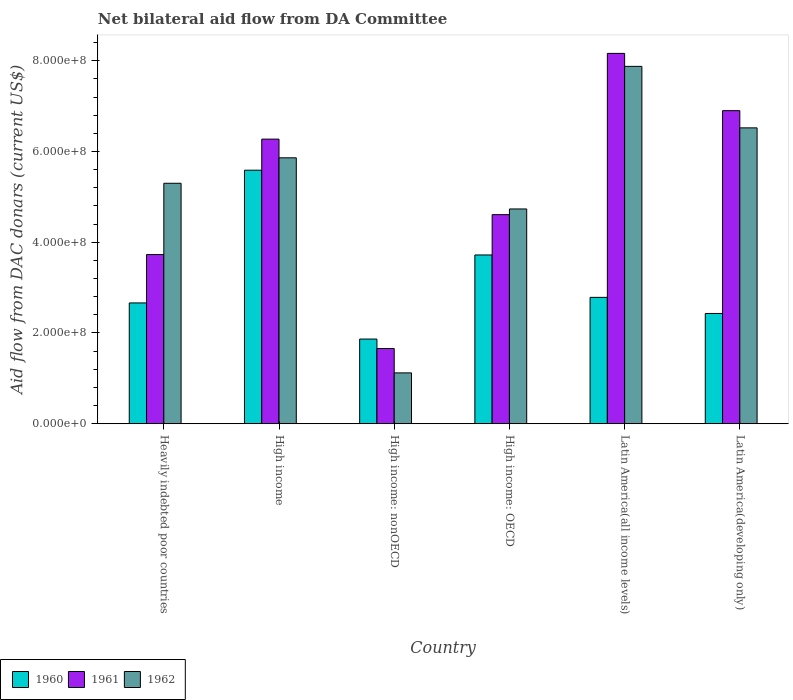How many groups of bars are there?
Provide a short and direct response. 6. How many bars are there on the 1st tick from the left?
Make the answer very short. 3. How many bars are there on the 5th tick from the right?
Your answer should be very brief. 3. What is the label of the 6th group of bars from the left?
Offer a terse response. Latin America(developing only). In how many cases, is the number of bars for a given country not equal to the number of legend labels?
Offer a very short reply. 0. What is the aid flow in in 1962 in High income: OECD?
Offer a very short reply. 4.73e+08. Across all countries, what is the maximum aid flow in in 1960?
Offer a very short reply. 5.59e+08. Across all countries, what is the minimum aid flow in in 1960?
Your answer should be compact. 1.87e+08. In which country was the aid flow in in 1960 maximum?
Offer a terse response. High income. In which country was the aid flow in in 1961 minimum?
Provide a succinct answer. High income: nonOECD. What is the total aid flow in in 1962 in the graph?
Offer a terse response. 3.14e+09. What is the difference between the aid flow in in 1961 in Heavily indebted poor countries and that in High income: nonOECD?
Give a very brief answer. 2.07e+08. What is the difference between the aid flow in in 1960 in High income: nonOECD and the aid flow in in 1961 in High income: OECD?
Your response must be concise. -2.74e+08. What is the average aid flow in in 1962 per country?
Offer a very short reply. 5.24e+08. What is the difference between the aid flow in of/in 1960 and aid flow in of/in 1961 in Latin America(all income levels)?
Your answer should be very brief. -5.38e+08. In how many countries, is the aid flow in in 1962 greater than 720000000 US$?
Your answer should be very brief. 1. What is the ratio of the aid flow in in 1962 in High income to that in Latin America(all income levels)?
Provide a succinct answer. 0.74. Is the aid flow in in 1961 in High income less than that in High income: nonOECD?
Your answer should be compact. No. What is the difference between the highest and the second highest aid flow in in 1960?
Provide a short and direct response. 1.87e+08. What is the difference between the highest and the lowest aid flow in in 1962?
Your answer should be compact. 6.76e+08. What does the 2nd bar from the left in High income represents?
Make the answer very short. 1961. Is it the case that in every country, the sum of the aid flow in in 1962 and aid flow in in 1960 is greater than the aid flow in in 1961?
Offer a very short reply. Yes. How many bars are there?
Provide a succinct answer. 18. How many countries are there in the graph?
Your answer should be compact. 6. Are the values on the major ticks of Y-axis written in scientific E-notation?
Provide a succinct answer. Yes. Does the graph contain grids?
Give a very brief answer. No. Where does the legend appear in the graph?
Keep it short and to the point. Bottom left. What is the title of the graph?
Provide a succinct answer. Net bilateral aid flow from DA Committee. What is the label or title of the Y-axis?
Ensure brevity in your answer.  Aid flow from DAC donars (current US$). What is the Aid flow from DAC donars (current US$) in 1960 in Heavily indebted poor countries?
Your answer should be very brief. 2.66e+08. What is the Aid flow from DAC donars (current US$) in 1961 in Heavily indebted poor countries?
Your response must be concise. 3.73e+08. What is the Aid flow from DAC donars (current US$) in 1962 in Heavily indebted poor countries?
Provide a short and direct response. 5.30e+08. What is the Aid flow from DAC donars (current US$) in 1960 in High income?
Provide a succinct answer. 5.59e+08. What is the Aid flow from DAC donars (current US$) of 1961 in High income?
Your answer should be very brief. 6.27e+08. What is the Aid flow from DAC donars (current US$) of 1962 in High income?
Ensure brevity in your answer.  5.86e+08. What is the Aid flow from DAC donars (current US$) of 1960 in High income: nonOECD?
Give a very brief answer. 1.87e+08. What is the Aid flow from DAC donars (current US$) of 1961 in High income: nonOECD?
Offer a very short reply. 1.66e+08. What is the Aid flow from DAC donars (current US$) of 1962 in High income: nonOECD?
Make the answer very short. 1.12e+08. What is the Aid flow from DAC donars (current US$) of 1960 in High income: OECD?
Your answer should be very brief. 3.72e+08. What is the Aid flow from DAC donars (current US$) in 1961 in High income: OECD?
Give a very brief answer. 4.61e+08. What is the Aid flow from DAC donars (current US$) of 1962 in High income: OECD?
Your answer should be very brief. 4.73e+08. What is the Aid flow from DAC donars (current US$) in 1960 in Latin America(all income levels)?
Give a very brief answer. 2.79e+08. What is the Aid flow from DAC donars (current US$) of 1961 in Latin America(all income levels)?
Give a very brief answer. 8.16e+08. What is the Aid flow from DAC donars (current US$) in 1962 in Latin America(all income levels)?
Your answer should be very brief. 7.88e+08. What is the Aid flow from DAC donars (current US$) in 1960 in Latin America(developing only)?
Keep it short and to the point. 2.43e+08. What is the Aid flow from DAC donars (current US$) in 1961 in Latin America(developing only)?
Provide a short and direct response. 6.90e+08. What is the Aid flow from DAC donars (current US$) of 1962 in Latin America(developing only)?
Provide a succinct answer. 6.52e+08. Across all countries, what is the maximum Aid flow from DAC donars (current US$) in 1960?
Your answer should be very brief. 5.59e+08. Across all countries, what is the maximum Aid flow from DAC donars (current US$) of 1961?
Ensure brevity in your answer.  8.16e+08. Across all countries, what is the maximum Aid flow from DAC donars (current US$) of 1962?
Ensure brevity in your answer.  7.88e+08. Across all countries, what is the minimum Aid flow from DAC donars (current US$) in 1960?
Provide a succinct answer. 1.87e+08. Across all countries, what is the minimum Aid flow from DAC donars (current US$) in 1961?
Provide a succinct answer. 1.66e+08. Across all countries, what is the minimum Aid flow from DAC donars (current US$) in 1962?
Ensure brevity in your answer.  1.12e+08. What is the total Aid flow from DAC donars (current US$) in 1960 in the graph?
Provide a succinct answer. 1.91e+09. What is the total Aid flow from DAC donars (current US$) of 1961 in the graph?
Offer a terse response. 3.13e+09. What is the total Aid flow from DAC donars (current US$) of 1962 in the graph?
Keep it short and to the point. 3.14e+09. What is the difference between the Aid flow from DAC donars (current US$) of 1960 in Heavily indebted poor countries and that in High income?
Keep it short and to the point. -2.92e+08. What is the difference between the Aid flow from DAC donars (current US$) in 1961 in Heavily indebted poor countries and that in High income?
Your answer should be very brief. -2.54e+08. What is the difference between the Aid flow from DAC donars (current US$) of 1962 in Heavily indebted poor countries and that in High income?
Provide a succinct answer. -5.61e+07. What is the difference between the Aid flow from DAC donars (current US$) in 1960 in Heavily indebted poor countries and that in High income: nonOECD?
Your answer should be very brief. 7.96e+07. What is the difference between the Aid flow from DAC donars (current US$) in 1961 in Heavily indebted poor countries and that in High income: nonOECD?
Your answer should be very brief. 2.07e+08. What is the difference between the Aid flow from DAC donars (current US$) in 1962 in Heavily indebted poor countries and that in High income: nonOECD?
Your answer should be very brief. 4.18e+08. What is the difference between the Aid flow from DAC donars (current US$) in 1960 in Heavily indebted poor countries and that in High income: OECD?
Give a very brief answer. -1.06e+08. What is the difference between the Aid flow from DAC donars (current US$) in 1961 in Heavily indebted poor countries and that in High income: OECD?
Offer a terse response. -8.80e+07. What is the difference between the Aid flow from DAC donars (current US$) of 1962 in Heavily indebted poor countries and that in High income: OECD?
Make the answer very short. 5.66e+07. What is the difference between the Aid flow from DAC donars (current US$) of 1960 in Heavily indebted poor countries and that in Latin America(all income levels)?
Ensure brevity in your answer.  -1.23e+07. What is the difference between the Aid flow from DAC donars (current US$) of 1961 in Heavily indebted poor countries and that in Latin America(all income levels)?
Offer a terse response. -4.43e+08. What is the difference between the Aid flow from DAC donars (current US$) in 1962 in Heavily indebted poor countries and that in Latin America(all income levels)?
Provide a short and direct response. -2.58e+08. What is the difference between the Aid flow from DAC donars (current US$) in 1960 in Heavily indebted poor countries and that in Latin America(developing only)?
Provide a short and direct response. 2.32e+07. What is the difference between the Aid flow from DAC donars (current US$) in 1961 in Heavily indebted poor countries and that in Latin America(developing only)?
Offer a very short reply. -3.17e+08. What is the difference between the Aid flow from DAC donars (current US$) in 1962 in Heavily indebted poor countries and that in Latin America(developing only)?
Your response must be concise. -1.22e+08. What is the difference between the Aid flow from DAC donars (current US$) in 1960 in High income and that in High income: nonOECD?
Your response must be concise. 3.72e+08. What is the difference between the Aid flow from DAC donars (current US$) in 1961 in High income and that in High income: nonOECD?
Provide a succinct answer. 4.61e+08. What is the difference between the Aid flow from DAC donars (current US$) in 1962 in High income and that in High income: nonOECD?
Your answer should be very brief. 4.74e+08. What is the difference between the Aid flow from DAC donars (current US$) of 1960 in High income and that in High income: OECD?
Give a very brief answer. 1.87e+08. What is the difference between the Aid flow from DAC donars (current US$) in 1961 in High income and that in High income: OECD?
Ensure brevity in your answer.  1.66e+08. What is the difference between the Aid flow from DAC donars (current US$) in 1962 in High income and that in High income: OECD?
Offer a very short reply. 1.13e+08. What is the difference between the Aid flow from DAC donars (current US$) of 1960 in High income and that in Latin America(all income levels)?
Give a very brief answer. 2.80e+08. What is the difference between the Aid flow from DAC donars (current US$) in 1961 in High income and that in Latin America(all income levels)?
Your answer should be very brief. -1.89e+08. What is the difference between the Aid flow from DAC donars (current US$) in 1962 in High income and that in Latin America(all income levels)?
Your response must be concise. -2.02e+08. What is the difference between the Aid flow from DAC donars (current US$) of 1960 in High income and that in Latin America(developing only)?
Keep it short and to the point. 3.16e+08. What is the difference between the Aid flow from DAC donars (current US$) of 1961 in High income and that in Latin America(developing only)?
Give a very brief answer. -6.27e+07. What is the difference between the Aid flow from DAC donars (current US$) of 1962 in High income and that in Latin America(developing only)?
Provide a short and direct response. -6.60e+07. What is the difference between the Aid flow from DAC donars (current US$) of 1960 in High income: nonOECD and that in High income: OECD?
Provide a succinct answer. -1.85e+08. What is the difference between the Aid flow from DAC donars (current US$) in 1961 in High income: nonOECD and that in High income: OECD?
Provide a succinct answer. -2.95e+08. What is the difference between the Aid flow from DAC donars (current US$) in 1962 in High income: nonOECD and that in High income: OECD?
Your answer should be very brief. -3.61e+08. What is the difference between the Aid flow from DAC donars (current US$) of 1960 in High income: nonOECD and that in Latin America(all income levels)?
Ensure brevity in your answer.  -9.19e+07. What is the difference between the Aid flow from DAC donars (current US$) of 1961 in High income: nonOECD and that in Latin America(all income levels)?
Give a very brief answer. -6.50e+08. What is the difference between the Aid flow from DAC donars (current US$) of 1962 in High income: nonOECD and that in Latin America(all income levels)?
Provide a short and direct response. -6.76e+08. What is the difference between the Aid flow from DAC donars (current US$) of 1960 in High income: nonOECD and that in Latin America(developing only)?
Ensure brevity in your answer.  -5.64e+07. What is the difference between the Aid flow from DAC donars (current US$) in 1961 in High income: nonOECD and that in Latin America(developing only)?
Offer a very short reply. -5.24e+08. What is the difference between the Aid flow from DAC donars (current US$) in 1962 in High income: nonOECD and that in Latin America(developing only)?
Offer a terse response. -5.40e+08. What is the difference between the Aid flow from DAC donars (current US$) in 1960 in High income: OECD and that in Latin America(all income levels)?
Your response must be concise. 9.35e+07. What is the difference between the Aid flow from DAC donars (current US$) of 1961 in High income: OECD and that in Latin America(all income levels)?
Your answer should be compact. -3.55e+08. What is the difference between the Aid flow from DAC donars (current US$) in 1962 in High income: OECD and that in Latin America(all income levels)?
Ensure brevity in your answer.  -3.14e+08. What is the difference between the Aid flow from DAC donars (current US$) of 1960 in High income: OECD and that in Latin America(developing only)?
Your answer should be compact. 1.29e+08. What is the difference between the Aid flow from DAC donars (current US$) of 1961 in High income: OECD and that in Latin America(developing only)?
Provide a succinct answer. -2.29e+08. What is the difference between the Aid flow from DAC donars (current US$) in 1962 in High income: OECD and that in Latin America(developing only)?
Keep it short and to the point. -1.79e+08. What is the difference between the Aid flow from DAC donars (current US$) of 1960 in Latin America(all income levels) and that in Latin America(developing only)?
Give a very brief answer. 3.55e+07. What is the difference between the Aid flow from DAC donars (current US$) in 1961 in Latin America(all income levels) and that in Latin America(developing only)?
Provide a succinct answer. 1.26e+08. What is the difference between the Aid flow from DAC donars (current US$) of 1962 in Latin America(all income levels) and that in Latin America(developing only)?
Make the answer very short. 1.36e+08. What is the difference between the Aid flow from DAC donars (current US$) of 1960 in Heavily indebted poor countries and the Aid flow from DAC donars (current US$) of 1961 in High income?
Keep it short and to the point. -3.61e+08. What is the difference between the Aid flow from DAC donars (current US$) of 1960 in Heavily indebted poor countries and the Aid flow from DAC donars (current US$) of 1962 in High income?
Provide a short and direct response. -3.20e+08. What is the difference between the Aid flow from DAC donars (current US$) in 1961 in Heavily indebted poor countries and the Aid flow from DAC donars (current US$) in 1962 in High income?
Your answer should be compact. -2.13e+08. What is the difference between the Aid flow from DAC donars (current US$) of 1960 in Heavily indebted poor countries and the Aid flow from DAC donars (current US$) of 1961 in High income: nonOECD?
Ensure brevity in your answer.  1.00e+08. What is the difference between the Aid flow from DAC donars (current US$) of 1960 in Heavily indebted poor countries and the Aid flow from DAC donars (current US$) of 1962 in High income: nonOECD?
Provide a succinct answer. 1.54e+08. What is the difference between the Aid flow from DAC donars (current US$) of 1961 in Heavily indebted poor countries and the Aid flow from DAC donars (current US$) of 1962 in High income: nonOECD?
Offer a very short reply. 2.61e+08. What is the difference between the Aid flow from DAC donars (current US$) of 1960 in Heavily indebted poor countries and the Aid flow from DAC donars (current US$) of 1961 in High income: OECD?
Your answer should be compact. -1.95e+08. What is the difference between the Aid flow from DAC donars (current US$) in 1960 in Heavily indebted poor countries and the Aid flow from DAC donars (current US$) in 1962 in High income: OECD?
Offer a very short reply. -2.07e+08. What is the difference between the Aid flow from DAC donars (current US$) in 1961 in Heavily indebted poor countries and the Aid flow from DAC donars (current US$) in 1962 in High income: OECD?
Ensure brevity in your answer.  -1.00e+08. What is the difference between the Aid flow from DAC donars (current US$) in 1960 in Heavily indebted poor countries and the Aid flow from DAC donars (current US$) in 1961 in Latin America(all income levels)?
Offer a very short reply. -5.50e+08. What is the difference between the Aid flow from DAC donars (current US$) of 1960 in Heavily indebted poor countries and the Aid flow from DAC donars (current US$) of 1962 in Latin America(all income levels)?
Offer a terse response. -5.21e+08. What is the difference between the Aid flow from DAC donars (current US$) in 1961 in Heavily indebted poor countries and the Aid flow from DAC donars (current US$) in 1962 in Latin America(all income levels)?
Keep it short and to the point. -4.15e+08. What is the difference between the Aid flow from DAC donars (current US$) of 1960 in Heavily indebted poor countries and the Aid flow from DAC donars (current US$) of 1961 in Latin America(developing only)?
Offer a terse response. -4.24e+08. What is the difference between the Aid flow from DAC donars (current US$) of 1960 in Heavily indebted poor countries and the Aid flow from DAC donars (current US$) of 1962 in Latin America(developing only)?
Provide a short and direct response. -3.86e+08. What is the difference between the Aid flow from DAC donars (current US$) of 1961 in Heavily indebted poor countries and the Aid flow from DAC donars (current US$) of 1962 in Latin America(developing only)?
Ensure brevity in your answer.  -2.79e+08. What is the difference between the Aid flow from DAC donars (current US$) in 1960 in High income and the Aid flow from DAC donars (current US$) in 1961 in High income: nonOECD?
Offer a very short reply. 3.93e+08. What is the difference between the Aid flow from DAC donars (current US$) in 1960 in High income and the Aid flow from DAC donars (current US$) in 1962 in High income: nonOECD?
Offer a very short reply. 4.47e+08. What is the difference between the Aid flow from DAC donars (current US$) in 1961 in High income and the Aid flow from DAC donars (current US$) in 1962 in High income: nonOECD?
Offer a very short reply. 5.15e+08. What is the difference between the Aid flow from DAC donars (current US$) of 1960 in High income and the Aid flow from DAC donars (current US$) of 1961 in High income: OECD?
Your answer should be compact. 9.79e+07. What is the difference between the Aid flow from DAC donars (current US$) of 1960 in High income and the Aid flow from DAC donars (current US$) of 1962 in High income: OECD?
Give a very brief answer. 8.54e+07. What is the difference between the Aid flow from DAC donars (current US$) of 1961 in High income and the Aid flow from DAC donars (current US$) of 1962 in High income: OECD?
Offer a terse response. 1.54e+08. What is the difference between the Aid flow from DAC donars (current US$) of 1960 in High income and the Aid flow from DAC donars (current US$) of 1961 in Latin America(all income levels)?
Your answer should be very brief. -2.57e+08. What is the difference between the Aid flow from DAC donars (current US$) in 1960 in High income and the Aid flow from DAC donars (current US$) in 1962 in Latin America(all income levels)?
Offer a very short reply. -2.29e+08. What is the difference between the Aid flow from DAC donars (current US$) of 1961 in High income and the Aid flow from DAC donars (current US$) of 1962 in Latin America(all income levels)?
Offer a very short reply. -1.60e+08. What is the difference between the Aid flow from DAC donars (current US$) in 1960 in High income and the Aid flow from DAC donars (current US$) in 1961 in Latin America(developing only)?
Your response must be concise. -1.31e+08. What is the difference between the Aid flow from DAC donars (current US$) of 1960 in High income and the Aid flow from DAC donars (current US$) of 1962 in Latin America(developing only)?
Your response must be concise. -9.33e+07. What is the difference between the Aid flow from DAC donars (current US$) of 1961 in High income and the Aid flow from DAC donars (current US$) of 1962 in Latin America(developing only)?
Keep it short and to the point. -2.48e+07. What is the difference between the Aid flow from DAC donars (current US$) of 1960 in High income: nonOECD and the Aid flow from DAC donars (current US$) of 1961 in High income: OECD?
Make the answer very short. -2.74e+08. What is the difference between the Aid flow from DAC donars (current US$) in 1960 in High income: nonOECD and the Aid flow from DAC donars (current US$) in 1962 in High income: OECD?
Make the answer very short. -2.87e+08. What is the difference between the Aid flow from DAC donars (current US$) in 1961 in High income: nonOECD and the Aid flow from DAC donars (current US$) in 1962 in High income: OECD?
Offer a terse response. -3.08e+08. What is the difference between the Aid flow from DAC donars (current US$) of 1960 in High income: nonOECD and the Aid flow from DAC donars (current US$) of 1961 in Latin America(all income levels)?
Offer a very short reply. -6.30e+08. What is the difference between the Aid flow from DAC donars (current US$) in 1960 in High income: nonOECD and the Aid flow from DAC donars (current US$) in 1962 in Latin America(all income levels)?
Ensure brevity in your answer.  -6.01e+08. What is the difference between the Aid flow from DAC donars (current US$) of 1961 in High income: nonOECD and the Aid flow from DAC donars (current US$) of 1962 in Latin America(all income levels)?
Offer a very short reply. -6.22e+08. What is the difference between the Aid flow from DAC donars (current US$) in 1960 in High income: nonOECD and the Aid flow from DAC donars (current US$) in 1961 in Latin America(developing only)?
Your response must be concise. -5.03e+08. What is the difference between the Aid flow from DAC donars (current US$) of 1960 in High income: nonOECD and the Aid flow from DAC donars (current US$) of 1962 in Latin America(developing only)?
Provide a short and direct response. -4.65e+08. What is the difference between the Aid flow from DAC donars (current US$) in 1961 in High income: nonOECD and the Aid flow from DAC donars (current US$) in 1962 in Latin America(developing only)?
Your answer should be very brief. -4.86e+08. What is the difference between the Aid flow from DAC donars (current US$) of 1960 in High income: OECD and the Aid flow from DAC donars (current US$) of 1961 in Latin America(all income levels)?
Offer a terse response. -4.44e+08. What is the difference between the Aid flow from DAC donars (current US$) of 1960 in High income: OECD and the Aid flow from DAC donars (current US$) of 1962 in Latin America(all income levels)?
Your response must be concise. -4.16e+08. What is the difference between the Aid flow from DAC donars (current US$) in 1961 in High income: OECD and the Aid flow from DAC donars (current US$) in 1962 in Latin America(all income levels)?
Make the answer very short. -3.27e+08. What is the difference between the Aid flow from DAC donars (current US$) in 1960 in High income: OECD and the Aid flow from DAC donars (current US$) in 1961 in Latin America(developing only)?
Provide a short and direct response. -3.18e+08. What is the difference between the Aid flow from DAC donars (current US$) of 1960 in High income: OECD and the Aid flow from DAC donars (current US$) of 1962 in Latin America(developing only)?
Keep it short and to the point. -2.80e+08. What is the difference between the Aid flow from DAC donars (current US$) in 1961 in High income: OECD and the Aid flow from DAC donars (current US$) in 1962 in Latin America(developing only)?
Your answer should be very brief. -1.91e+08. What is the difference between the Aid flow from DAC donars (current US$) of 1960 in Latin America(all income levels) and the Aid flow from DAC donars (current US$) of 1961 in Latin America(developing only)?
Your answer should be compact. -4.11e+08. What is the difference between the Aid flow from DAC donars (current US$) of 1960 in Latin America(all income levels) and the Aid flow from DAC donars (current US$) of 1962 in Latin America(developing only)?
Ensure brevity in your answer.  -3.74e+08. What is the difference between the Aid flow from DAC donars (current US$) of 1961 in Latin America(all income levels) and the Aid flow from DAC donars (current US$) of 1962 in Latin America(developing only)?
Give a very brief answer. 1.64e+08. What is the average Aid flow from DAC donars (current US$) in 1960 per country?
Make the answer very short. 3.18e+08. What is the average Aid flow from DAC donars (current US$) of 1961 per country?
Make the answer very short. 5.22e+08. What is the average Aid flow from DAC donars (current US$) in 1962 per country?
Provide a succinct answer. 5.24e+08. What is the difference between the Aid flow from DAC donars (current US$) in 1960 and Aid flow from DAC donars (current US$) in 1961 in Heavily indebted poor countries?
Provide a succinct answer. -1.07e+08. What is the difference between the Aid flow from DAC donars (current US$) of 1960 and Aid flow from DAC donars (current US$) of 1962 in Heavily indebted poor countries?
Your answer should be very brief. -2.64e+08. What is the difference between the Aid flow from DAC donars (current US$) in 1961 and Aid flow from DAC donars (current US$) in 1962 in Heavily indebted poor countries?
Your answer should be compact. -1.57e+08. What is the difference between the Aid flow from DAC donars (current US$) of 1960 and Aid flow from DAC donars (current US$) of 1961 in High income?
Ensure brevity in your answer.  -6.85e+07. What is the difference between the Aid flow from DAC donars (current US$) in 1960 and Aid flow from DAC donars (current US$) in 1962 in High income?
Provide a succinct answer. -2.73e+07. What is the difference between the Aid flow from DAC donars (current US$) in 1961 and Aid flow from DAC donars (current US$) in 1962 in High income?
Offer a terse response. 4.12e+07. What is the difference between the Aid flow from DAC donars (current US$) in 1960 and Aid flow from DAC donars (current US$) in 1961 in High income: nonOECD?
Keep it short and to the point. 2.08e+07. What is the difference between the Aid flow from DAC donars (current US$) in 1960 and Aid flow from DAC donars (current US$) in 1962 in High income: nonOECD?
Ensure brevity in your answer.  7.46e+07. What is the difference between the Aid flow from DAC donars (current US$) in 1961 and Aid flow from DAC donars (current US$) in 1962 in High income: nonOECD?
Your answer should be very brief. 5.37e+07. What is the difference between the Aid flow from DAC donars (current US$) of 1960 and Aid flow from DAC donars (current US$) of 1961 in High income: OECD?
Your answer should be very brief. -8.88e+07. What is the difference between the Aid flow from DAC donars (current US$) in 1960 and Aid flow from DAC donars (current US$) in 1962 in High income: OECD?
Ensure brevity in your answer.  -1.01e+08. What is the difference between the Aid flow from DAC donars (current US$) in 1961 and Aid flow from DAC donars (current US$) in 1962 in High income: OECD?
Offer a very short reply. -1.26e+07. What is the difference between the Aid flow from DAC donars (current US$) of 1960 and Aid flow from DAC donars (current US$) of 1961 in Latin America(all income levels)?
Your answer should be very brief. -5.38e+08. What is the difference between the Aid flow from DAC donars (current US$) in 1960 and Aid flow from DAC donars (current US$) in 1962 in Latin America(all income levels)?
Make the answer very short. -5.09e+08. What is the difference between the Aid flow from DAC donars (current US$) of 1961 and Aid flow from DAC donars (current US$) of 1962 in Latin America(all income levels)?
Make the answer very short. 2.86e+07. What is the difference between the Aid flow from DAC donars (current US$) in 1960 and Aid flow from DAC donars (current US$) in 1961 in Latin America(developing only)?
Your answer should be compact. -4.47e+08. What is the difference between the Aid flow from DAC donars (current US$) of 1960 and Aid flow from DAC donars (current US$) of 1962 in Latin America(developing only)?
Your response must be concise. -4.09e+08. What is the difference between the Aid flow from DAC donars (current US$) in 1961 and Aid flow from DAC donars (current US$) in 1962 in Latin America(developing only)?
Ensure brevity in your answer.  3.79e+07. What is the ratio of the Aid flow from DAC donars (current US$) in 1960 in Heavily indebted poor countries to that in High income?
Provide a succinct answer. 0.48. What is the ratio of the Aid flow from DAC donars (current US$) in 1961 in Heavily indebted poor countries to that in High income?
Your answer should be compact. 0.59. What is the ratio of the Aid flow from DAC donars (current US$) of 1962 in Heavily indebted poor countries to that in High income?
Make the answer very short. 0.9. What is the ratio of the Aid flow from DAC donars (current US$) in 1960 in Heavily indebted poor countries to that in High income: nonOECD?
Keep it short and to the point. 1.43. What is the ratio of the Aid flow from DAC donars (current US$) in 1961 in Heavily indebted poor countries to that in High income: nonOECD?
Your response must be concise. 2.25. What is the ratio of the Aid flow from DAC donars (current US$) in 1962 in Heavily indebted poor countries to that in High income: nonOECD?
Offer a terse response. 4.73. What is the ratio of the Aid flow from DAC donars (current US$) in 1960 in Heavily indebted poor countries to that in High income: OECD?
Keep it short and to the point. 0.72. What is the ratio of the Aid flow from DAC donars (current US$) of 1961 in Heavily indebted poor countries to that in High income: OECD?
Make the answer very short. 0.81. What is the ratio of the Aid flow from DAC donars (current US$) in 1962 in Heavily indebted poor countries to that in High income: OECD?
Offer a very short reply. 1.12. What is the ratio of the Aid flow from DAC donars (current US$) of 1960 in Heavily indebted poor countries to that in Latin America(all income levels)?
Your response must be concise. 0.96. What is the ratio of the Aid flow from DAC donars (current US$) in 1961 in Heavily indebted poor countries to that in Latin America(all income levels)?
Provide a succinct answer. 0.46. What is the ratio of the Aid flow from DAC donars (current US$) in 1962 in Heavily indebted poor countries to that in Latin America(all income levels)?
Offer a very short reply. 0.67. What is the ratio of the Aid flow from DAC donars (current US$) in 1960 in Heavily indebted poor countries to that in Latin America(developing only)?
Offer a terse response. 1.1. What is the ratio of the Aid flow from DAC donars (current US$) of 1961 in Heavily indebted poor countries to that in Latin America(developing only)?
Your response must be concise. 0.54. What is the ratio of the Aid flow from DAC donars (current US$) in 1962 in Heavily indebted poor countries to that in Latin America(developing only)?
Your answer should be very brief. 0.81. What is the ratio of the Aid flow from DAC donars (current US$) of 1960 in High income to that in High income: nonOECD?
Ensure brevity in your answer.  2.99. What is the ratio of the Aid flow from DAC donars (current US$) of 1961 in High income to that in High income: nonOECD?
Your response must be concise. 3.78. What is the ratio of the Aid flow from DAC donars (current US$) in 1962 in High income to that in High income: nonOECD?
Provide a short and direct response. 5.23. What is the ratio of the Aid flow from DAC donars (current US$) of 1960 in High income to that in High income: OECD?
Your answer should be compact. 1.5. What is the ratio of the Aid flow from DAC donars (current US$) in 1961 in High income to that in High income: OECD?
Make the answer very short. 1.36. What is the ratio of the Aid flow from DAC donars (current US$) in 1962 in High income to that in High income: OECD?
Your response must be concise. 1.24. What is the ratio of the Aid flow from DAC donars (current US$) in 1960 in High income to that in Latin America(all income levels)?
Your answer should be compact. 2.01. What is the ratio of the Aid flow from DAC donars (current US$) in 1961 in High income to that in Latin America(all income levels)?
Ensure brevity in your answer.  0.77. What is the ratio of the Aid flow from DAC donars (current US$) in 1962 in High income to that in Latin America(all income levels)?
Provide a succinct answer. 0.74. What is the ratio of the Aid flow from DAC donars (current US$) of 1960 in High income to that in Latin America(developing only)?
Your response must be concise. 2.3. What is the ratio of the Aid flow from DAC donars (current US$) of 1961 in High income to that in Latin America(developing only)?
Provide a short and direct response. 0.91. What is the ratio of the Aid flow from DAC donars (current US$) of 1962 in High income to that in Latin America(developing only)?
Provide a short and direct response. 0.9. What is the ratio of the Aid flow from DAC donars (current US$) in 1960 in High income: nonOECD to that in High income: OECD?
Your answer should be compact. 0.5. What is the ratio of the Aid flow from DAC donars (current US$) in 1961 in High income: nonOECD to that in High income: OECD?
Offer a very short reply. 0.36. What is the ratio of the Aid flow from DAC donars (current US$) in 1962 in High income: nonOECD to that in High income: OECD?
Make the answer very short. 0.24. What is the ratio of the Aid flow from DAC donars (current US$) in 1960 in High income: nonOECD to that in Latin America(all income levels)?
Keep it short and to the point. 0.67. What is the ratio of the Aid flow from DAC donars (current US$) of 1961 in High income: nonOECD to that in Latin America(all income levels)?
Offer a terse response. 0.2. What is the ratio of the Aid flow from DAC donars (current US$) in 1962 in High income: nonOECD to that in Latin America(all income levels)?
Your response must be concise. 0.14. What is the ratio of the Aid flow from DAC donars (current US$) in 1960 in High income: nonOECD to that in Latin America(developing only)?
Give a very brief answer. 0.77. What is the ratio of the Aid flow from DAC donars (current US$) of 1961 in High income: nonOECD to that in Latin America(developing only)?
Ensure brevity in your answer.  0.24. What is the ratio of the Aid flow from DAC donars (current US$) of 1962 in High income: nonOECD to that in Latin America(developing only)?
Offer a terse response. 0.17. What is the ratio of the Aid flow from DAC donars (current US$) in 1960 in High income: OECD to that in Latin America(all income levels)?
Ensure brevity in your answer.  1.34. What is the ratio of the Aid flow from DAC donars (current US$) of 1961 in High income: OECD to that in Latin America(all income levels)?
Your answer should be very brief. 0.56. What is the ratio of the Aid flow from DAC donars (current US$) of 1962 in High income: OECD to that in Latin America(all income levels)?
Provide a succinct answer. 0.6. What is the ratio of the Aid flow from DAC donars (current US$) in 1960 in High income: OECD to that in Latin America(developing only)?
Your answer should be compact. 1.53. What is the ratio of the Aid flow from DAC donars (current US$) of 1961 in High income: OECD to that in Latin America(developing only)?
Make the answer very short. 0.67. What is the ratio of the Aid flow from DAC donars (current US$) in 1962 in High income: OECD to that in Latin America(developing only)?
Offer a very short reply. 0.73. What is the ratio of the Aid flow from DAC donars (current US$) of 1960 in Latin America(all income levels) to that in Latin America(developing only)?
Give a very brief answer. 1.15. What is the ratio of the Aid flow from DAC donars (current US$) of 1961 in Latin America(all income levels) to that in Latin America(developing only)?
Your answer should be very brief. 1.18. What is the ratio of the Aid flow from DAC donars (current US$) in 1962 in Latin America(all income levels) to that in Latin America(developing only)?
Your answer should be very brief. 1.21. What is the difference between the highest and the second highest Aid flow from DAC donars (current US$) in 1960?
Your answer should be compact. 1.87e+08. What is the difference between the highest and the second highest Aid flow from DAC donars (current US$) of 1961?
Offer a terse response. 1.26e+08. What is the difference between the highest and the second highest Aid flow from DAC donars (current US$) in 1962?
Keep it short and to the point. 1.36e+08. What is the difference between the highest and the lowest Aid flow from DAC donars (current US$) of 1960?
Your response must be concise. 3.72e+08. What is the difference between the highest and the lowest Aid flow from DAC donars (current US$) of 1961?
Keep it short and to the point. 6.50e+08. What is the difference between the highest and the lowest Aid flow from DAC donars (current US$) of 1962?
Your answer should be very brief. 6.76e+08. 